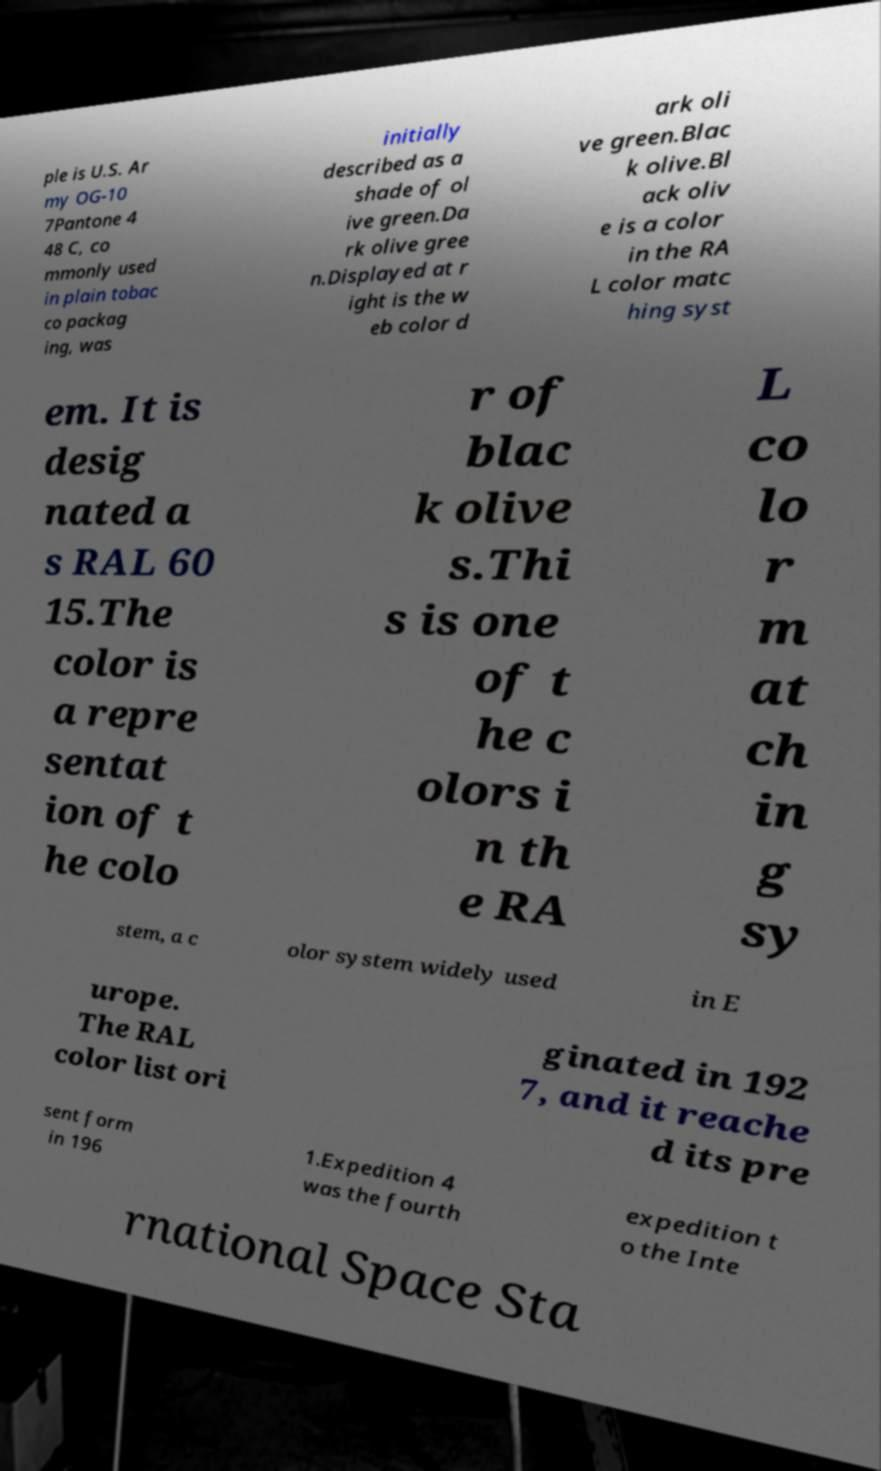There's text embedded in this image that I need extracted. Can you transcribe it verbatim? ple is U.S. Ar my OG-10 7Pantone 4 48 C, co mmonly used in plain tobac co packag ing, was initially described as a shade of ol ive green.Da rk olive gree n.Displayed at r ight is the w eb color d ark oli ve green.Blac k olive.Bl ack oliv e is a color in the RA L color matc hing syst em. It is desig nated a s RAL 60 15.The color is a repre sentat ion of t he colo r of blac k olive s.Thi s is one of t he c olors i n th e RA L co lo r m at ch in g sy stem, a c olor system widely used in E urope. The RAL color list ori ginated in 192 7, and it reache d its pre sent form in 196 1.Expedition 4 was the fourth expedition t o the Inte rnational Space Sta 